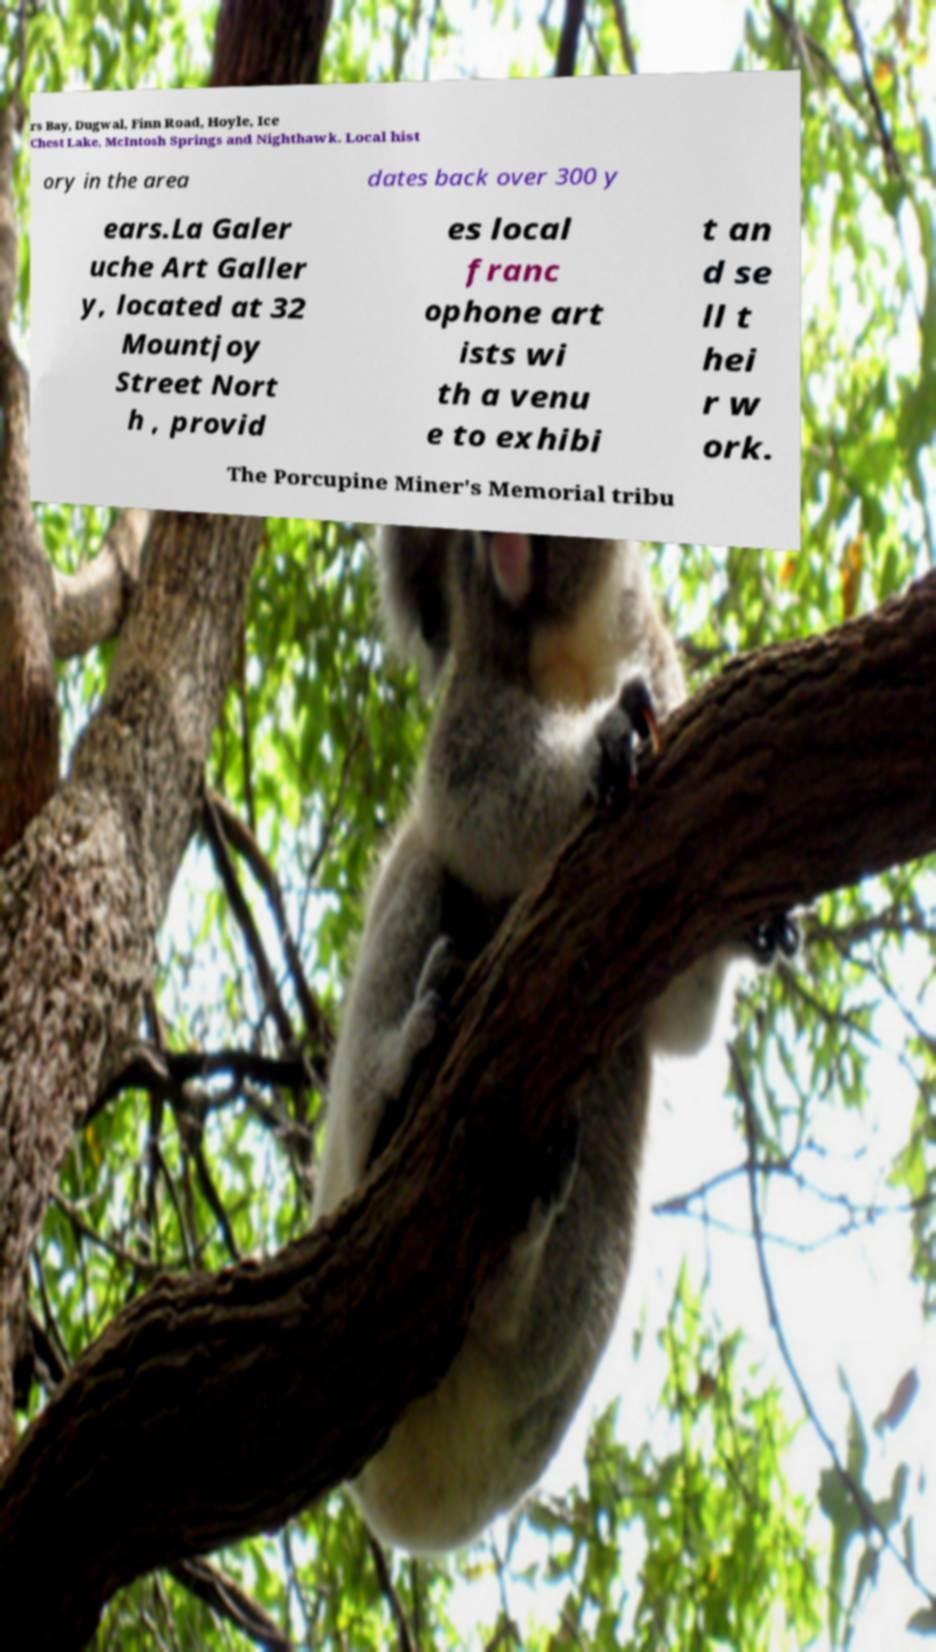What messages or text are displayed in this image? I need them in a readable, typed format. rs Bay, Dugwal, Finn Road, Hoyle, Ice Chest Lake, McIntosh Springs and Nighthawk. Local hist ory in the area dates back over 300 y ears.La Galer uche Art Galler y, located at 32 Mountjoy Street Nort h , provid es local franc ophone art ists wi th a venu e to exhibi t an d se ll t hei r w ork. The Porcupine Miner's Memorial tribu 